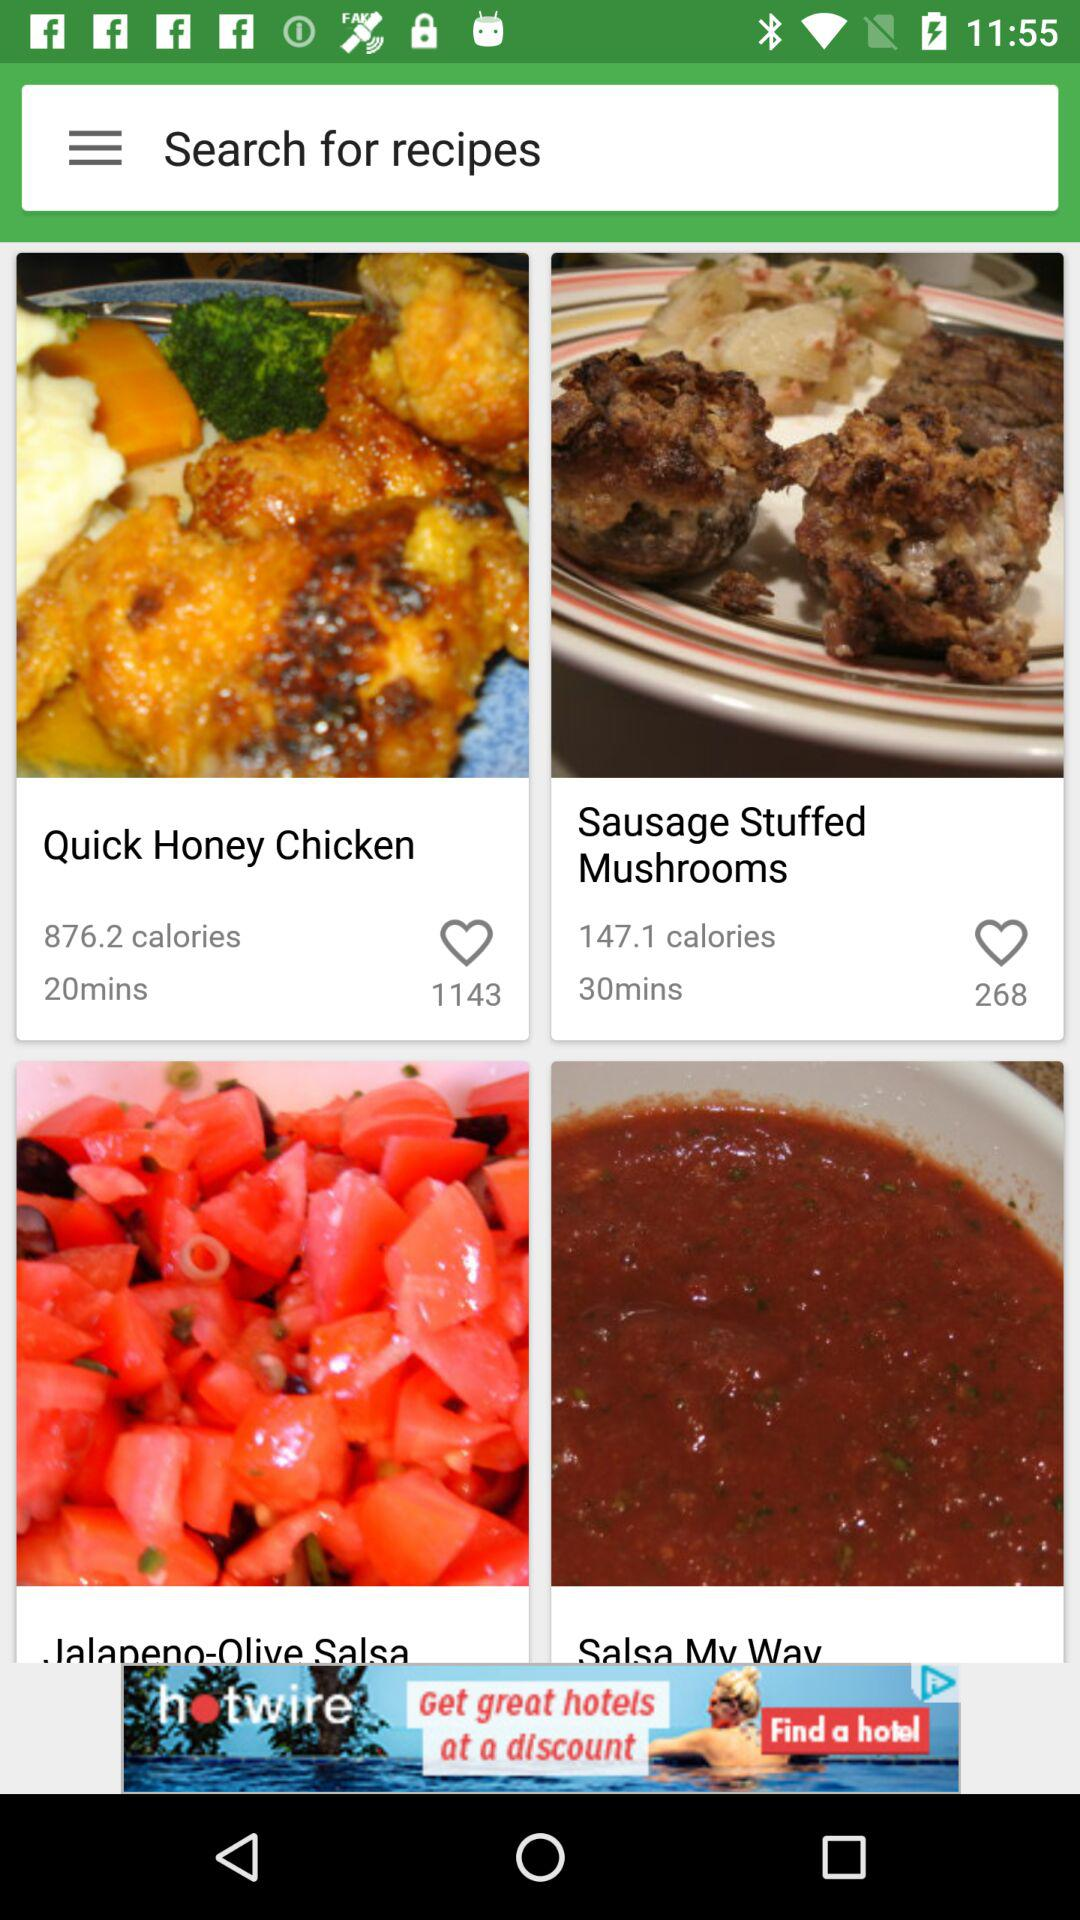How many likes did the "Quick Honey Chicken" get? The "Quick Honey Chicken" got 1143 likes. 